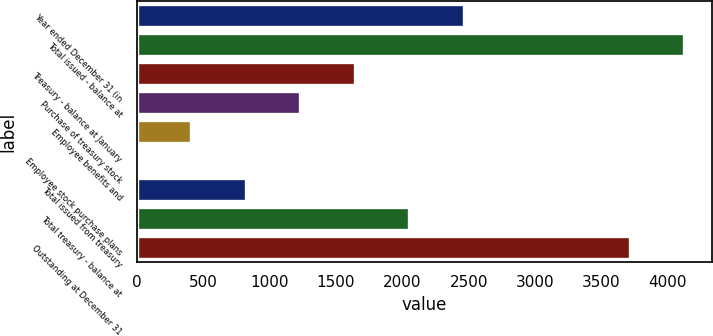<chart> <loc_0><loc_0><loc_500><loc_500><bar_chart><fcel>Year ended December 31 (in<fcel>Total issued - balance at<fcel>Treasury - balance at January<fcel>Purchase of treasury stock<fcel>Employee benefits and<fcel>Employee stock purchase plans<fcel>Total issued from treasury<fcel>Total treasury - balance at<fcel>Outstanding at December 31<nl><fcel>2463.42<fcel>4125.17<fcel>1642.68<fcel>1232.31<fcel>411.57<fcel>1.2<fcel>821.94<fcel>2053.05<fcel>3714.8<nl></chart> 